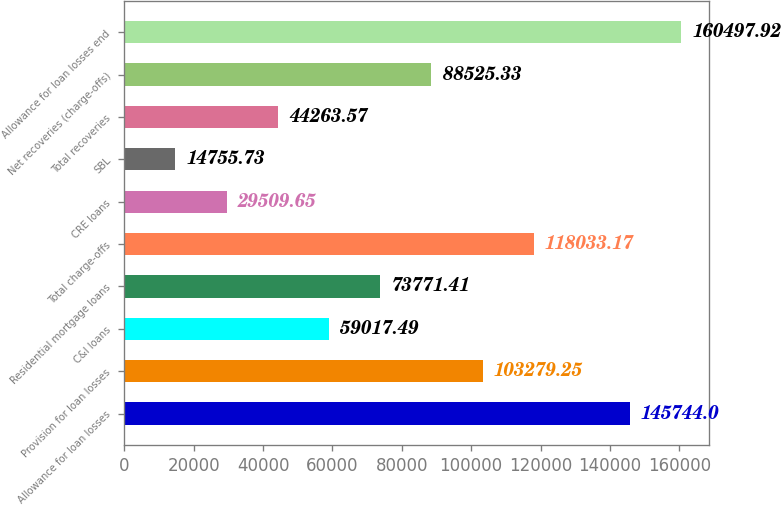Convert chart. <chart><loc_0><loc_0><loc_500><loc_500><bar_chart><fcel>Allowance for loan losses<fcel>Provision for loan losses<fcel>C&I loans<fcel>Residential mortgage loans<fcel>Total charge-offs<fcel>CRE loans<fcel>SBL<fcel>Total recoveries<fcel>Net recoveries (charge-offs)<fcel>Allowance for loan losses end<nl><fcel>145744<fcel>103279<fcel>59017.5<fcel>73771.4<fcel>118033<fcel>29509.7<fcel>14755.7<fcel>44263.6<fcel>88525.3<fcel>160498<nl></chart> 